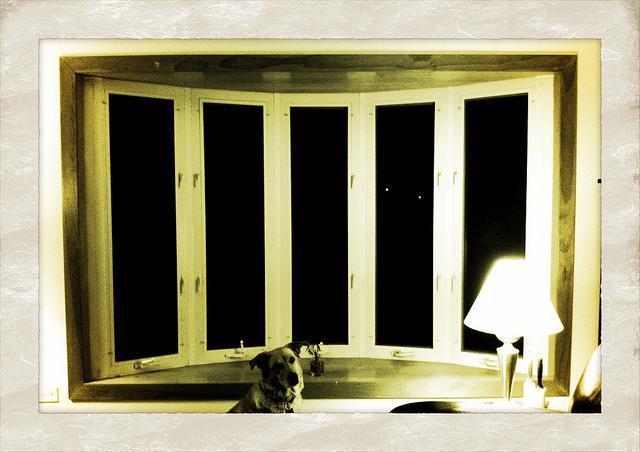How many people are sitting in the front row?
Give a very brief answer. 0. 